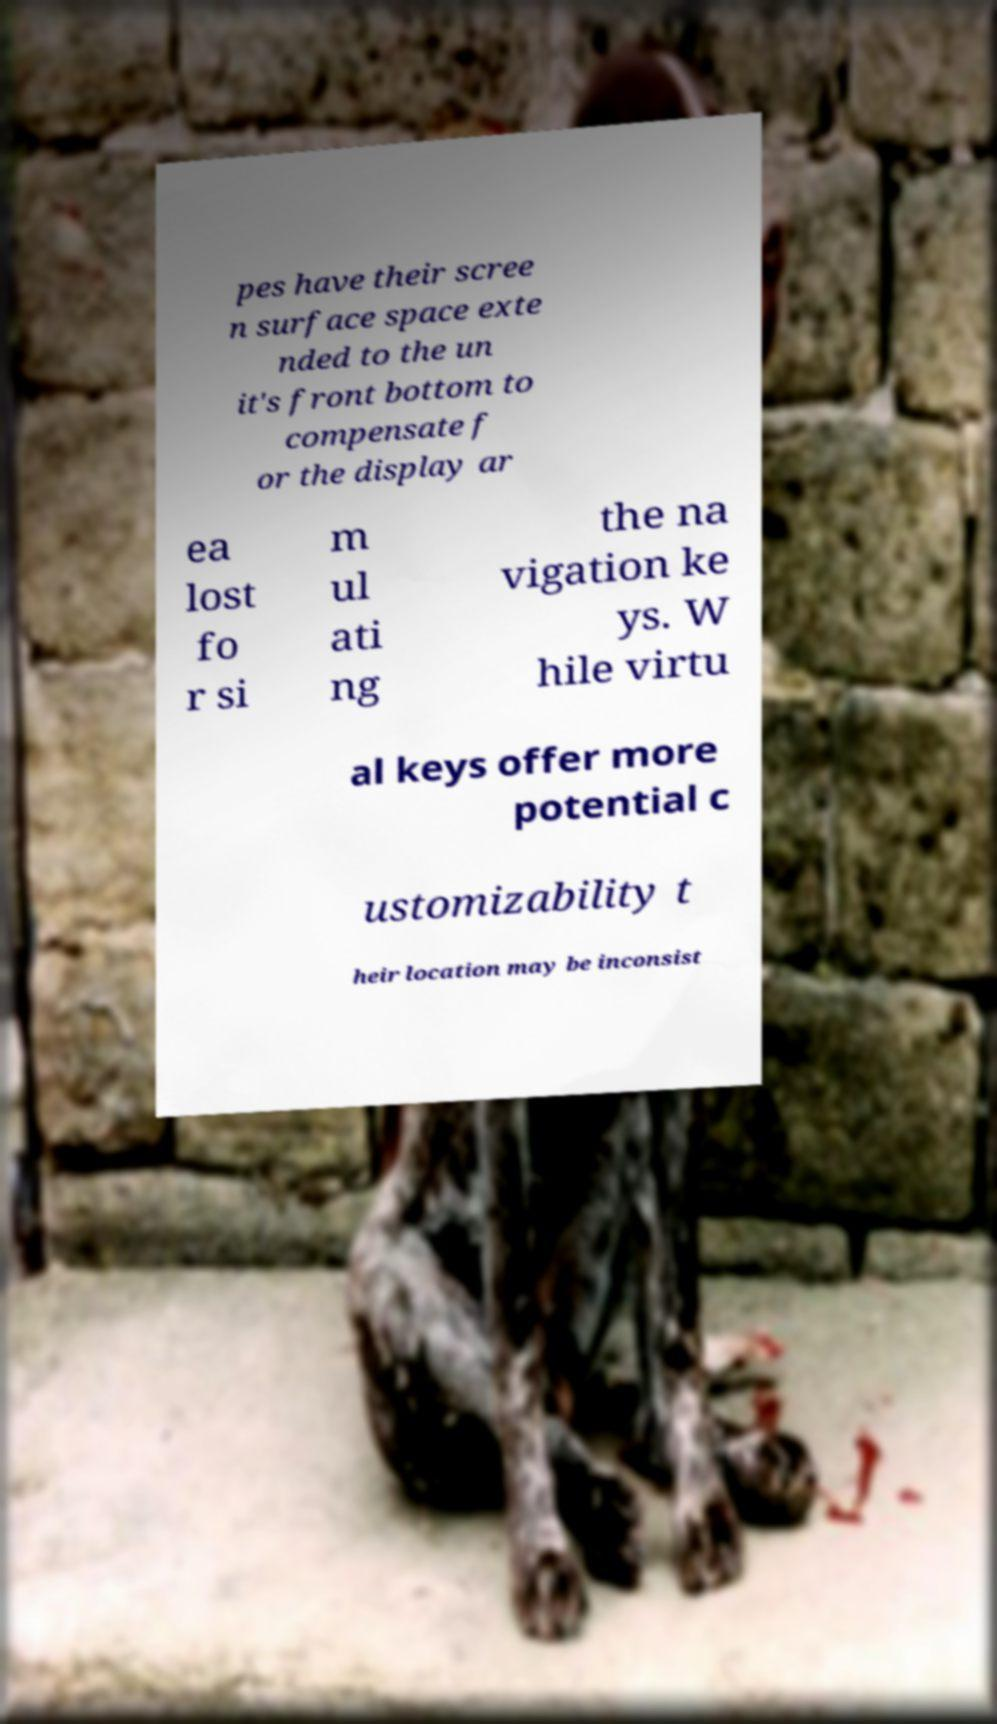Please read and relay the text visible in this image. What does it say? pes have their scree n surface space exte nded to the un it's front bottom to compensate f or the display ar ea lost fo r si m ul ati ng the na vigation ke ys. W hile virtu al keys offer more potential c ustomizability t heir location may be inconsist 